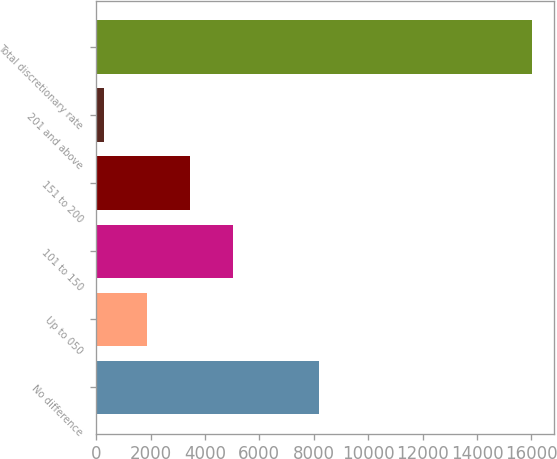Convert chart. <chart><loc_0><loc_0><loc_500><loc_500><bar_chart><fcel>No difference<fcel>Up to 050<fcel>101 to 150<fcel>151 to 200<fcel>201 and above<fcel>Total discretionary rate<nl><fcel>8180.1<fcel>1875.99<fcel>5018.77<fcel>3447.38<fcel>304.6<fcel>16018.5<nl></chart> 